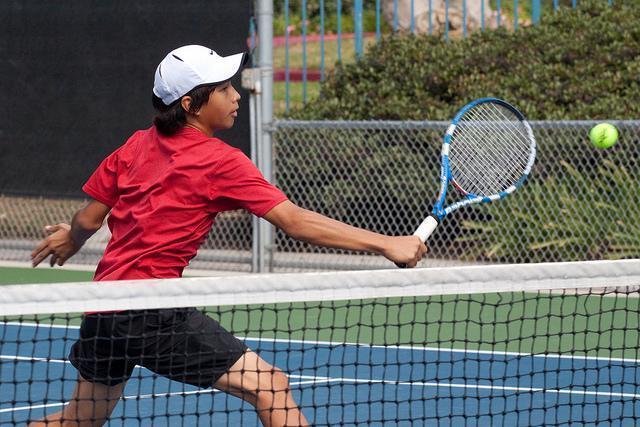Why is the boy reaching for the ball?
From the following four choices, select the correct answer to address the question.
Options: To throw, to show, to hit, to catch. To hit. 